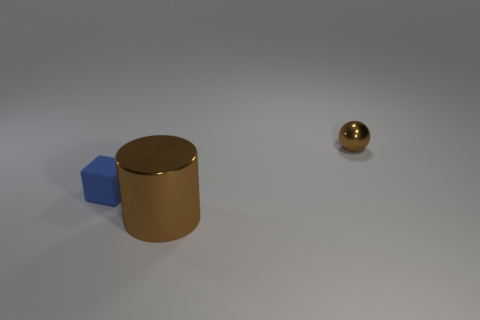Is the brown object on the left side of the small metal sphere made of the same material as the small ball?
Provide a succinct answer. Yes. How many big things are yellow matte balls or blue matte objects?
Your response must be concise. 0. There is a shiny thing that is behind the big thing; does it have the same color as the big cylinder?
Ensure brevity in your answer.  Yes. Does the metal thing that is behind the cylinder have the same color as the thing in front of the small blue matte object?
Offer a terse response. Yes. Is there a brown cylinder made of the same material as the small ball?
Your answer should be very brief. Yes. What number of brown objects are small rubber blocks or cylinders?
Your response must be concise. 1. Are there more brown spheres that are on the right side of the big metal cylinder than tiny objects?
Offer a terse response. No. Is the size of the blue thing the same as the brown sphere?
Ensure brevity in your answer.  Yes. What is the color of the large cylinder that is made of the same material as the small ball?
Keep it short and to the point. Brown. There is a object that is the same color as the tiny metal ball; what is its shape?
Provide a short and direct response. Cylinder. 